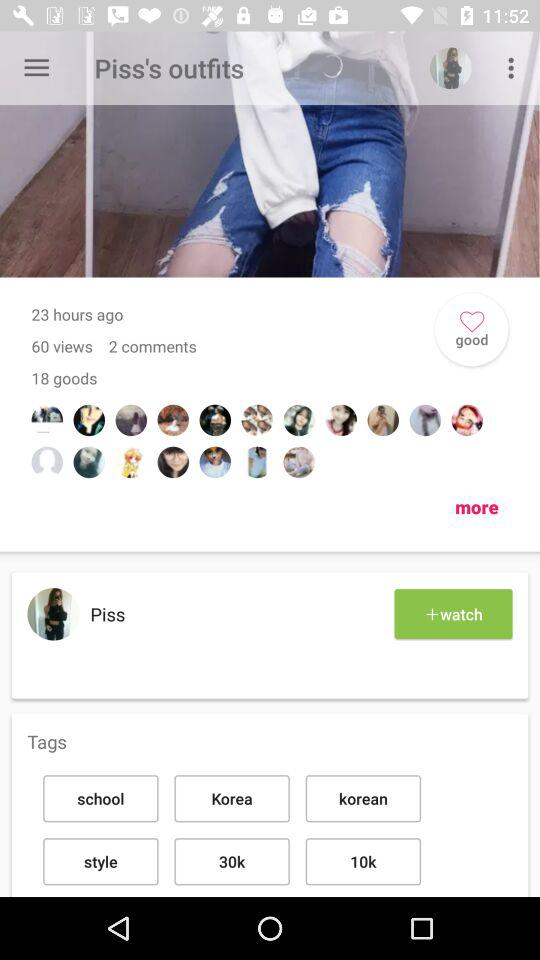How many comments are there? There are 2 comments. 